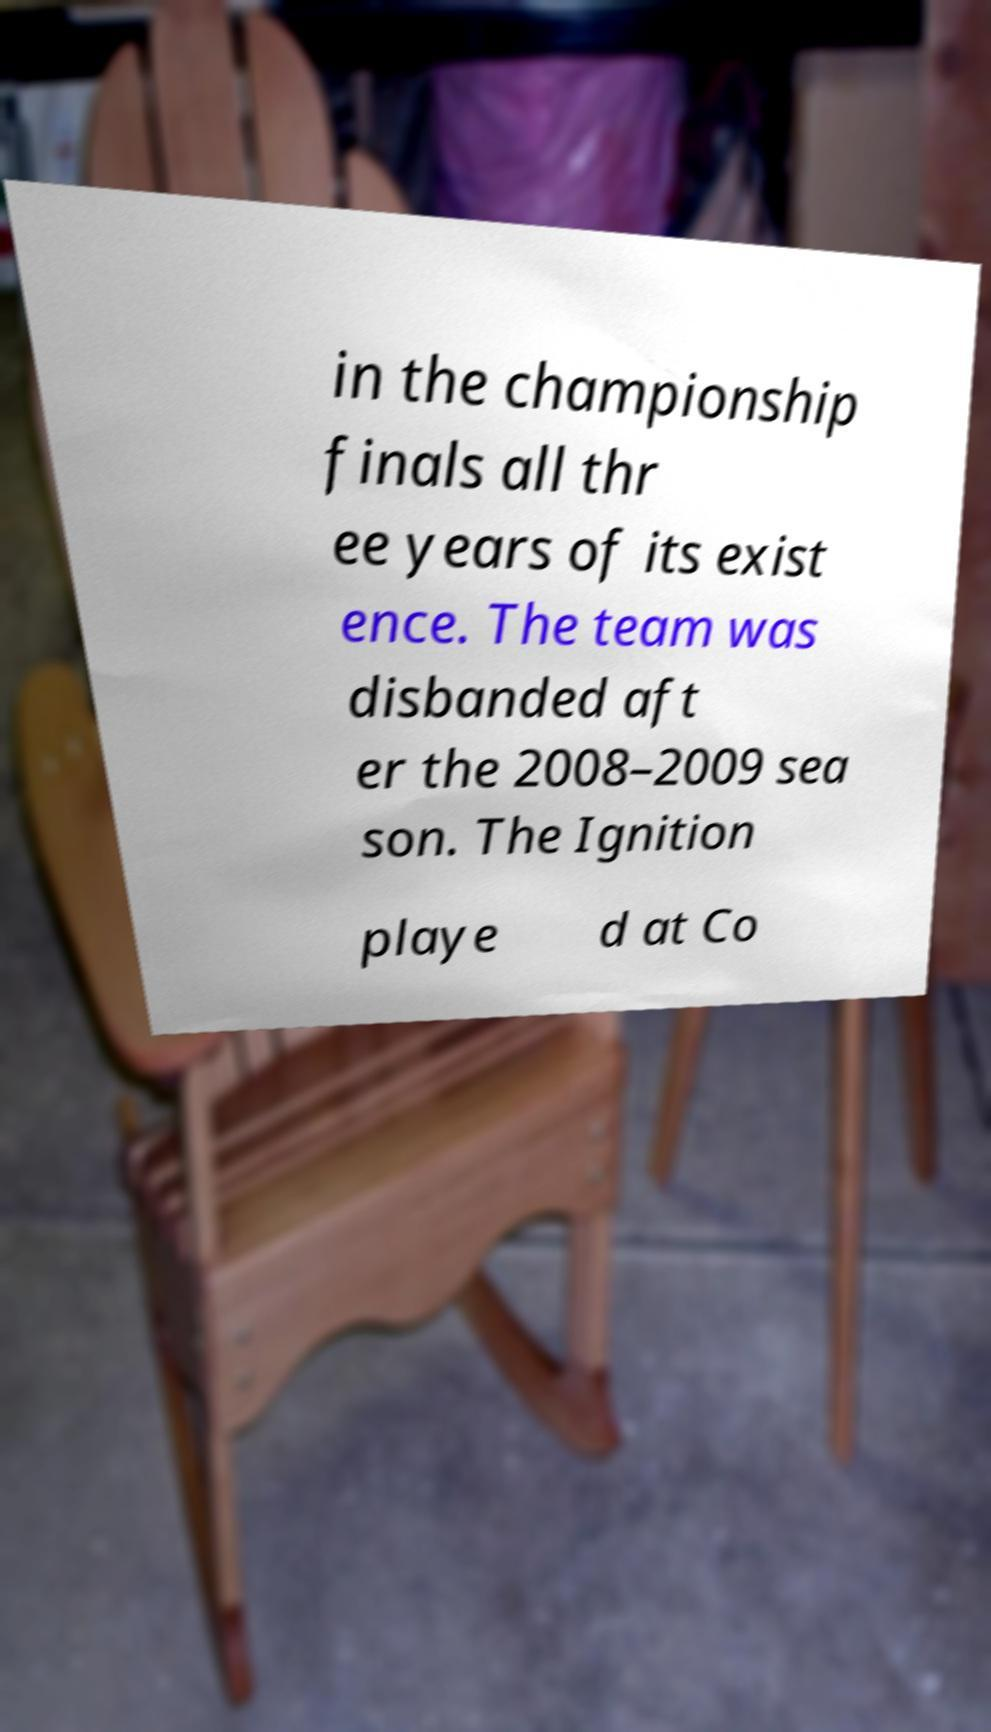Can you accurately transcribe the text from the provided image for me? in the championship finals all thr ee years of its exist ence. The team was disbanded aft er the 2008–2009 sea son. The Ignition playe d at Co 